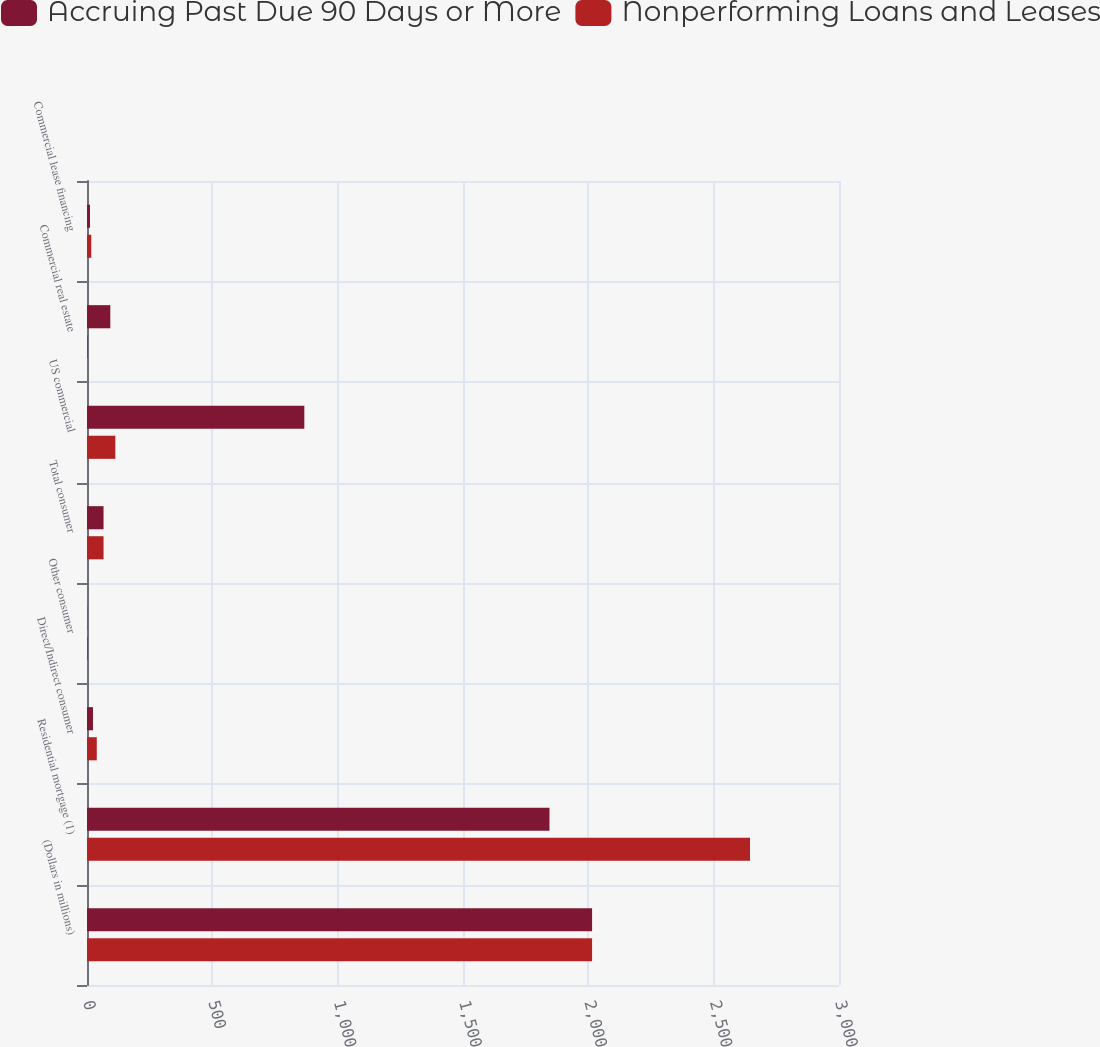<chart> <loc_0><loc_0><loc_500><loc_500><stacked_bar_chart><ecel><fcel>(Dollars in millions)<fcel>Residential mortgage (1)<fcel>Direct/Indirect consumer<fcel>Other consumer<fcel>Total consumer<fcel>US commercial<fcel>Commercial real estate<fcel>Commercial lease financing<nl><fcel>Accruing Past Due 90 Days or More<fcel>2015<fcel>1845<fcel>24<fcel>1<fcel>66<fcel>867<fcel>93<fcel>12<nl><fcel>Nonperforming Loans and Leases<fcel>2015<fcel>2645<fcel>39<fcel>3<fcel>66<fcel>113<fcel>3<fcel>17<nl></chart> 